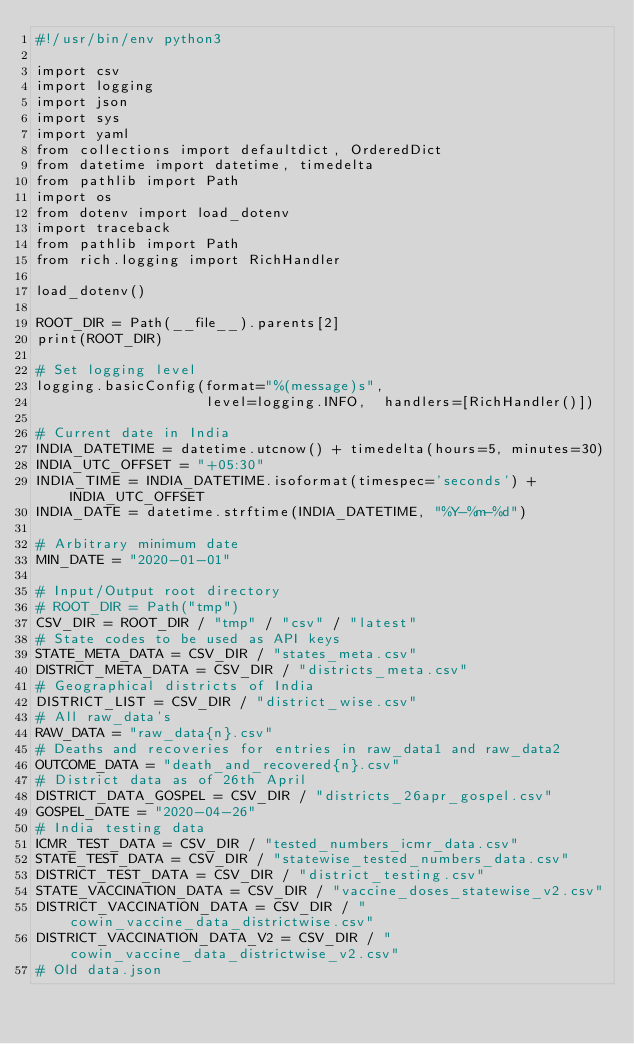<code> <loc_0><loc_0><loc_500><loc_500><_Python_>#!/usr/bin/env python3

import csv
import logging
import json
import sys
import yaml
from collections import defaultdict, OrderedDict
from datetime import datetime, timedelta
from pathlib import Path
import os
from dotenv import load_dotenv
import traceback
from pathlib import Path
from rich.logging import RichHandler

load_dotenv()

ROOT_DIR = Path(__file__).parents[2]
print(ROOT_DIR)

# Set logging level
logging.basicConfig(format="%(message)s",
                    level=logging.INFO,  handlers=[RichHandler()])

# Current date in India
INDIA_DATETIME = datetime.utcnow() + timedelta(hours=5, minutes=30)
INDIA_UTC_OFFSET = "+05:30"
INDIA_TIME = INDIA_DATETIME.isoformat(timespec='seconds') + INDIA_UTC_OFFSET
INDIA_DATE = datetime.strftime(INDIA_DATETIME, "%Y-%m-%d")

# Arbitrary minimum date
MIN_DATE = "2020-01-01"

# Input/Output root directory
# ROOT_DIR = Path("tmp")
CSV_DIR = ROOT_DIR / "tmp" / "csv" / "latest"
# State codes to be used as API keys
STATE_META_DATA = CSV_DIR / "states_meta.csv"
DISTRICT_META_DATA = CSV_DIR / "districts_meta.csv"
# Geographical districts of India
DISTRICT_LIST = CSV_DIR / "district_wise.csv"
# All raw_data's
RAW_DATA = "raw_data{n}.csv"
# Deaths and recoveries for entries in raw_data1 and raw_data2
OUTCOME_DATA = "death_and_recovered{n}.csv"
# District data as of 26th April
DISTRICT_DATA_GOSPEL = CSV_DIR / "districts_26apr_gospel.csv"
GOSPEL_DATE = "2020-04-26"
# India testing data
ICMR_TEST_DATA = CSV_DIR / "tested_numbers_icmr_data.csv"
STATE_TEST_DATA = CSV_DIR / "statewise_tested_numbers_data.csv"
DISTRICT_TEST_DATA = CSV_DIR / "district_testing.csv"
STATE_VACCINATION_DATA = CSV_DIR / "vaccine_doses_statewise_v2.csv"
DISTRICT_VACCINATION_DATA = CSV_DIR / "cowin_vaccine_data_districtwise.csv"
DISTRICT_VACCINATION_DATA_V2 = CSV_DIR / "cowin_vaccine_data_districtwise_v2.csv"
# Old data.json</code> 